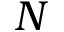<formula> <loc_0><loc_0><loc_500><loc_500>N</formula> 